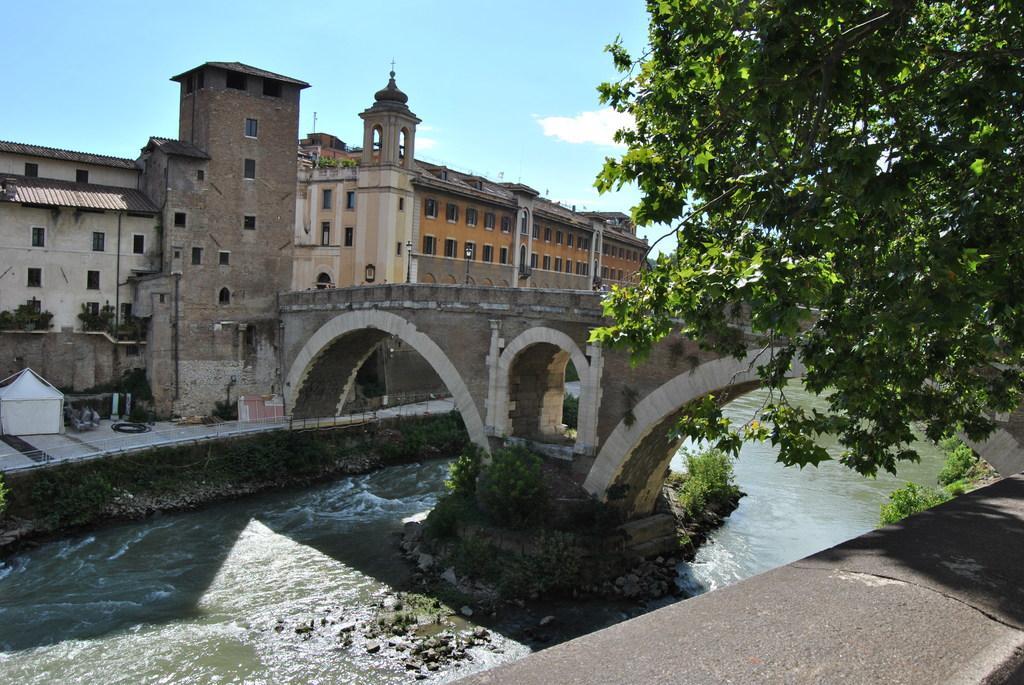Please provide a concise description of this image. In this image I can see the water, the bridge, few trees which are green in color, few buildings, a white colored tent and few windows of the buildings. In the background I can see the sky. 